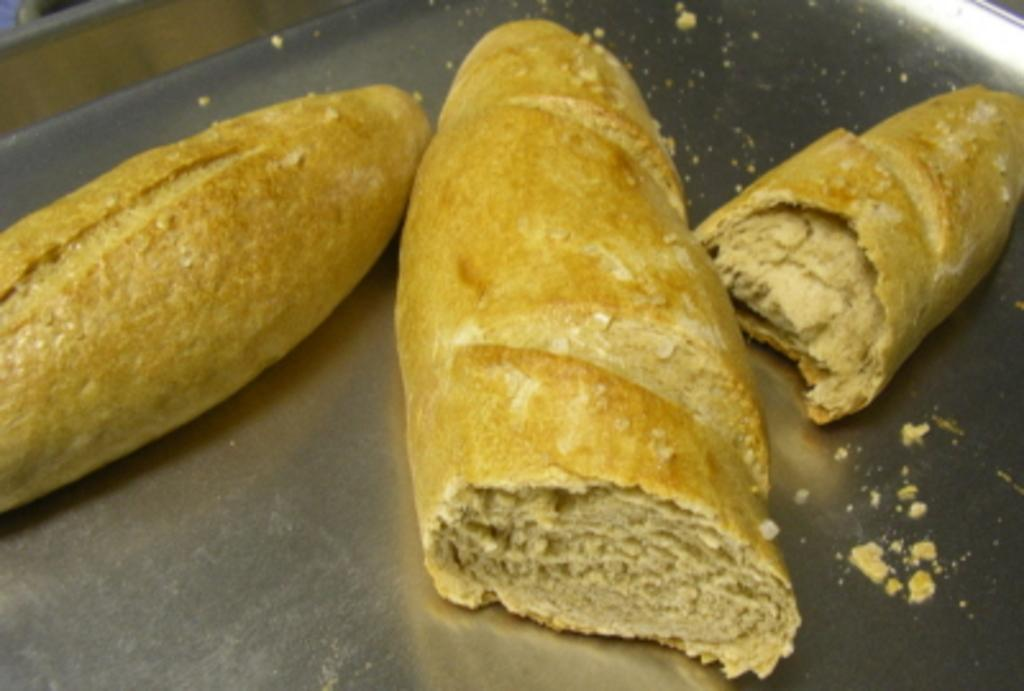What type of objects can be seen in the image? There are food items in the image. How are the food items arranged or organized? The food items are in a tray. What type of rhythm can be heard from the governor in the image? There is no governor or rhythm present in the image; it only features food items in a tray. 